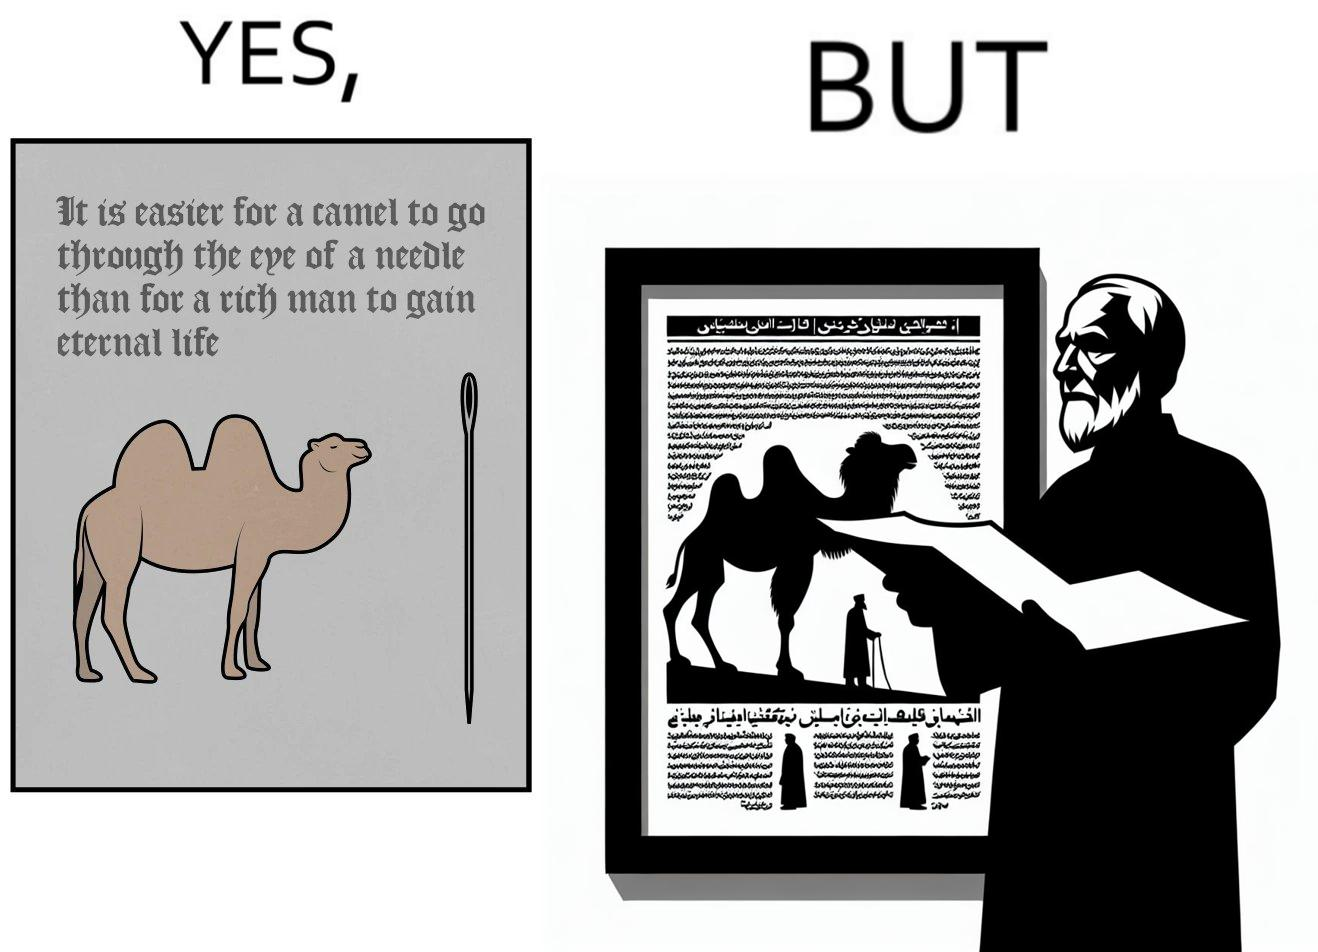Provide a description of this image. The image is ironic, because an old man with good looking clothes, symbolising him as rich, is showing a quote on the difficulty for a rich man to gain eternal life whereas the man has both long life meaning eternal life and good clothes meaning rich 